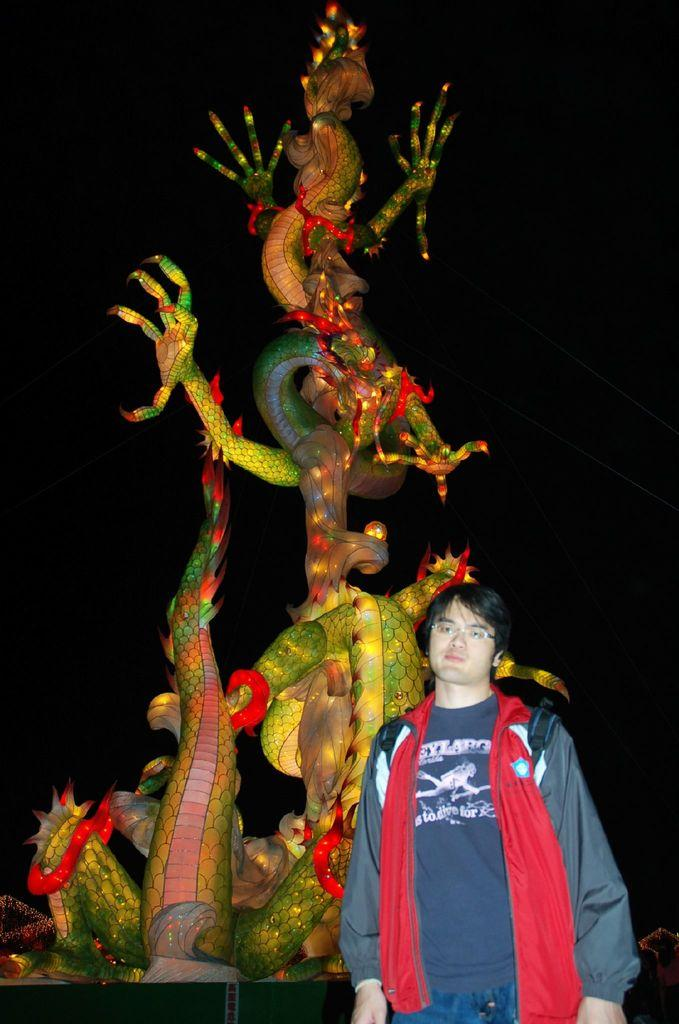Who is present in the image? There is a man in the image. What is the man wearing? The man is wearing spectacles. What can be seen behind the man in the image? There are lights visible behind the man. What type of statue is in the image? There is a dragon statue in the image. What type of toothbrush is the man using in the image? There is no toothbrush present in the image. What type of plough can be seen in the background of the image? There is no plough present in the image; it features lights and a dragon statue. 